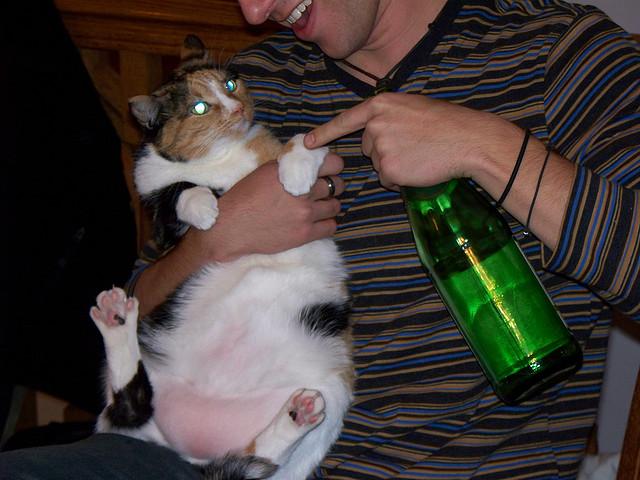Which animal is this?
Short answer required. Cat. What is the water bottle resting on?
Concise answer only. Chest. What color bottle is the man holding?
Give a very brief answer. Green. What is the man holding?
Keep it brief. Cat. 